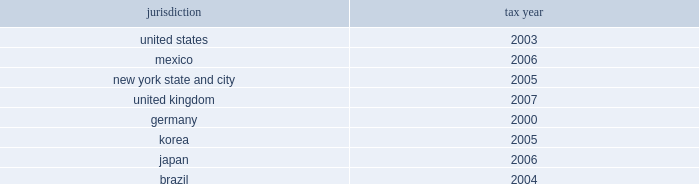The company is currently under audit by the internal revenue service and other major taxing jurisdictions around the world .
It is thus reasonably possible that significant changes in the gross balance of unrecognized tax benefits may occur within the next 12 months , but the company does not expect such audits to result in amounts that would cause a significant change to its effective tax rate , other than the following items .
The company is currently at irs appeals for the years 1999 20132002 .
One of the issues relates to the timing of the inclusion of interchange fees received by the company relating to credit card purchases by its cardholders .
It is reasonably possible that within the next 12 months the company can either reach agreement on this issue at appeals or decide to litigate the issue .
This issue is presently being litigated by another company in a united states tax court case .
The gross uncertain tax position for this item at december 31 , 2008 is $ 542 million .
Since this is a temporary difference , the only effect to the company 2019s effective tax rate would be due to net interest and state tax rate differentials .
If the reserve were to be released , the tax benefit could be as much as $ 168 million .
In addition , the company expects to conclude the irs audit of its u.s .
Federal consolidated income tax returns for the years 2003 20132005 within the next 12 months .
The gross uncertain tax position at december 31 , 2008 for the items expected to be resolved is approximately $ 350 million plus gross interest of $ 70 million .
The potential net tax benefit to continuing operations could be approximately $ 325 million .
The following are the major tax jurisdictions in which the company and its affiliates operate and the earliest tax year subject to examination: .
Foreign pretax earnings approximated $ 10.3 billion in 2008 , $ 9.1 billion in 2007 , and $ 13.6 billion in 2006 ( $ 5.1 billion , $ 0.7 billion and $ 0.9 billion of which , respectively , are in discontinued operations ) .
As a u.s .
Corporation , citigroup and its u.s .
Subsidiaries are subject to u.s .
Taxation currently on all foreign pretax earnings earned by a foreign branch .
Pretax earnings of a foreign subsidiary or affiliate are subject to u.s .
Taxation when effectively repatriated .
The company provides income taxes on the undistributed earnings of non-u.s .
Subsidiaries except to the extent that such earnings are indefinitely invested outside the united states .
At december 31 , 2008 , $ 22.8 billion of accumulated undistributed earnings of non-u.s .
Subsidiaries were indefinitely invested .
At the existing u.s .
Federal income tax rate , additional taxes ( net of u.s .
Foreign tax credits ) of $ 6.1 billion would have to be provided if such earnings were remitted currently .
The current year 2019s effect on the income tax expense from continuing operations is included in the foreign income tax rate differential line in the reconciliation of the federal statutory rate to the company 2019s effective income tax rate on the previous page .
Income taxes are not provided for on the company 2019s savings bank base year bad debt reserves that arose before 1988 because under current u.s .
Tax rules such taxes will become payable only to the extent such amounts are distributed in excess of limits prescribed by federal law .
At december 31 , 2008 , the amount of the base year reserves totaled approximately $ 358 million ( subject to a tax of $ 125 million ) .
The company has no valuation allowance on deferred tax assets at december 31 , 2008 and december 31 , 2007 .
At december 31 , 2008 , the company had a u.s .
Foreign tax-credit carryforward of $ 10.5 billion , $ 0.4 billion whose expiry date is 2016 , $ 5.3 billion whose expiry date is 2017 and $ 4.8 billion whose expiry date is 2018 .
The company has a u.s federal consolidated net operating loss ( nol ) carryforward of approximately $ 13 billion whose expiration date is 2028 .
The company also has a general business credit carryforward of $ 0.6 billion whose expiration dates are 2027-2028 .
The company has state and local net operating loss carryforwards of $ 16.2 billion and $ 4.9 billion in new york state and new york city , respectively .
This consists of $ 2.4 billion and $ 1.2 billion , whose expiration date is 2027 and $ 13.8 billion and $ 3.7 billion whose expiration date is 2028 and for which the company has recorded a deferred-tax asset of $ 1.2 billion , along with less significant net operating losses in various other states for which the company has recorded a deferred-tax asset of $ 399 million and which expire between 2012 and 2028 .
In addition , the company has recorded deferred-tax assets in apb 23 subsidiaries for foreign net operating loss carryforwards of $ 130 million ( which expires in 2018 ) and $ 101 million ( with no expiration ) .
Although realization is not assured , the company believes that the realization of the recognized net deferred tax asset of $ 44.5 billion is more likely than not based on expectations as to future taxable income in the jurisdictions in which it operates and available tax planning strategies , as defined in sfas 109 , that could be implemented if necessary to prevent a carryforward from expiring .
The company 2019s net deferred tax asset ( dta ) of $ 44.5 billion consists of approximately $ 36.5 billion of net u.s .
Federal dtas , $ 4 billion of net state dtas and $ 4 billion of net foreign dtas .
Included in the net federal dta of $ 36.5 billion are deferred tax liabilities of $ 4 billion that will reverse in the relevant carryforward period and may be used to support the dta .
The major components of the u.s .
Federal dta are $ 10.5 billion in foreign tax-credit carryforwards , $ 4.6 billion in a net-operating-loss carryforward , $ 0.6 billion in a general-business-credit carryforward , $ 19.9 billion in net deductions that have not yet been taken on a tax return , and $ 0.9 billion in compensation deductions , which reduced additional paid-in capital in january 2009 and for which sfas 123 ( r ) did not permit any adjustment to such dta at december 31 , 2008 because the related stock compensation was not yet deductible to the company .
In general , citigroup would need to generate approximately $ 85 billion of taxable income during the respective carryforward periods to fully realize its federal , state and local dtas. .
What percent of foreign pretax earnings in 2008 were from discontinued operations? 
Computations: (5.1 / 10.3)
Answer: 0.49515. 